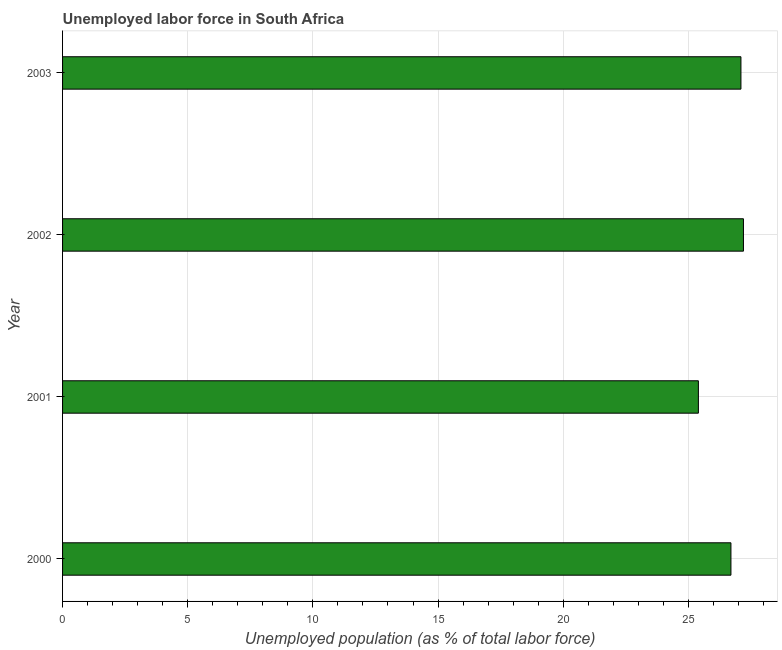What is the title of the graph?
Offer a very short reply. Unemployed labor force in South Africa. What is the label or title of the X-axis?
Provide a succinct answer. Unemployed population (as % of total labor force). What is the total unemployed population in 2001?
Provide a short and direct response. 25.4. Across all years, what is the maximum total unemployed population?
Give a very brief answer. 27.2. Across all years, what is the minimum total unemployed population?
Keep it short and to the point. 25.4. In which year was the total unemployed population minimum?
Your answer should be very brief. 2001. What is the sum of the total unemployed population?
Provide a succinct answer. 106.4. What is the average total unemployed population per year?
Your response must be concise. 26.6. What is the median total unemployed population?
Ensure brevity in your answer.  26.9. Do a majority of the years between 2002 and 2001 (inclusive) have total unemployed population greater than 21 %?
Offer a very short reply. No. What is the ratio of the total unemployed population in 2000 to that in 2003?
Provide a succinct answer. 0.98. Is the total unemployed population in 2002 less than that in 2003?
Ensure brevity in your answer.  No. Is the difference between the total unemployed population in 2001 and 2002 greater than the difference between any two years?
Your answer should be very brief. Yes. How many bars are there?
Your response must be concise. 4. How many years are there in the graph?
Make the answer very short. 4. What is the Unemployed population (as % of total labor force) of 2000?
Give a very brief answer. 26.7. What is the Unemployed population (as % of total labor force) in 2001?
Offer a terse response. 25.4. What is the Unemployed population (as % of total labor force) of 2002?
Provide a short and direct response. 27.2. What is the Unemployed population (as % of total labor force) in 2003?
Make the answer very short. 27.1. What is the difference between the Unemployed population (as % of total labor force) in 2000 and 2002?
Your answer should be very brief. -0.5. What is the difference between the Unemployed population (as % of total labor force) in 2000 and 2003?
Your response must be concise. -0.4. What is the difference between the Unemployed population (as % of total labor force) in 2001 and 2002?
Provide a short and direct response. -1.8. What is the difference between the Unemployed population (as % of total labor force) in 2002 and 2003?
Offer a very short reply. 0.1. What is the ratio of the Unemployed population (as % of total labor force) in 2000 to that in 2001?
Give a very brief answer. 1.05. What is the ratio of the Unemployed population (as % of total labor force) in 2001 to that in 2002?
Offer a terse response. 0.93. What is the ratio of the Unemployed population (as % of total labor force) in 2001 to that in 2003?
Provide a short and direct response. 0.94. What is the ratio of the Unemployed population (as % of total labor force) in 2002 to that in 2003?
Keep it short and to the point. 1. 